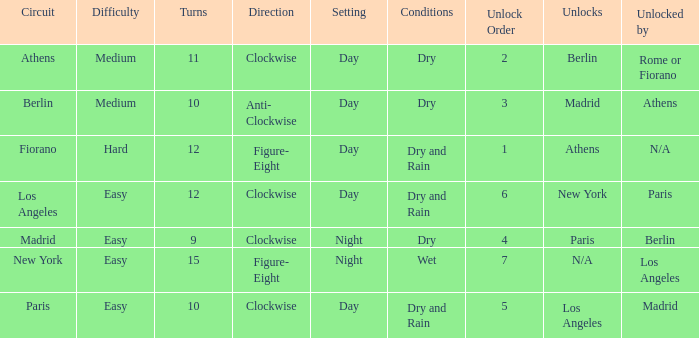How many instances is paris the unlock? 1.0. 